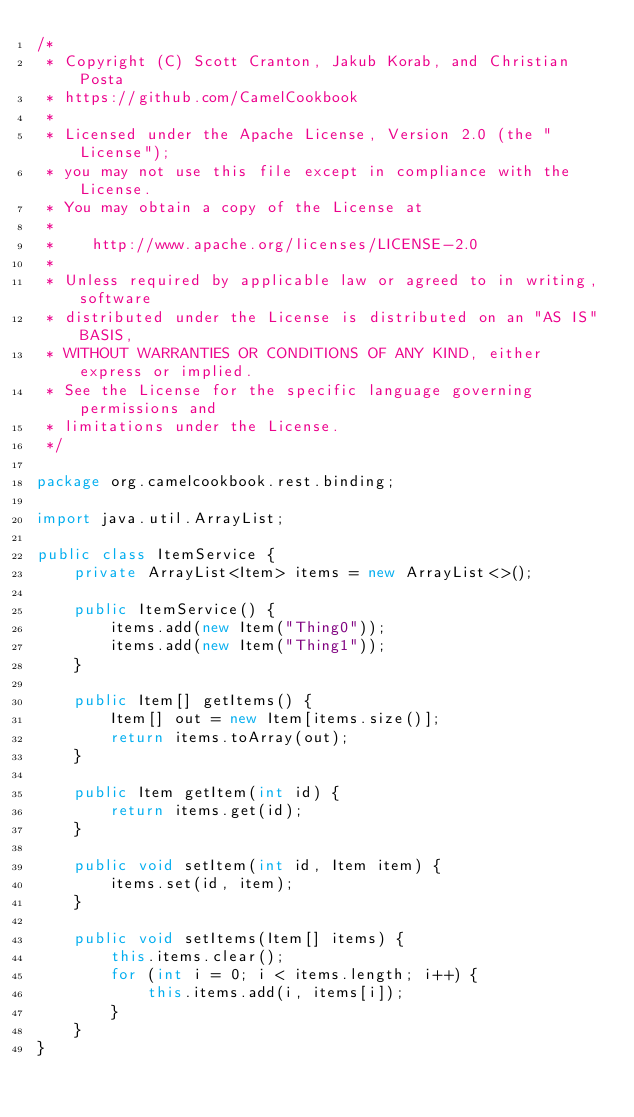<code> <loc_0><loc_0><loc_500><loc_500><_Java_>/*
 * Copyright (C) Scott Cranton, Jakub Korab, and Christian Posta
 * https://github.com/CamelCookbook
 *
 * Licensed under the Apache License, Version 2.0 (the "License");
 * you may not use this file except in compliance with the License.
 * You may obtain a copy of the License at
 *
 *    http://www.apache.org/licenses/LICENSE-2.0
 *
 * Unless required by applicable law or agreed to in writing, software
 * distributed under the License is distributed on an "AS IS" BASIS,
 * WITHOUT WARRANTIES OR CONDITIONS OF ANY KIND, either express or implied.
 * See the License for the specific language governing permissions and
 * limitations under the License.
 */

package org.camelcookbook.rest.binding;

import java.util.ArrayList;

public class ItemService {
    private ArrayList<Item> items = new ArrayList<>();

    public ItemService() {
        items.add(new Item("Thing0"));
        items.add(new Item("Thing1"));
    }

    public Item[] getItems() {
        Item[] out = new Item[items.size()];
        return items.toArray(out);
    }

    public Item getItem(int id) {
        return items.get(id);
    }

    public void setItem(int id, Item item) {
        items.set(id, item);
    }

    public void setItems(Item[] items) {
        this.items.clear();
        for (int i = 0; i < items.length; i++) {
            this.items.add(i, items[i]);
        }
    }
}
</code> 